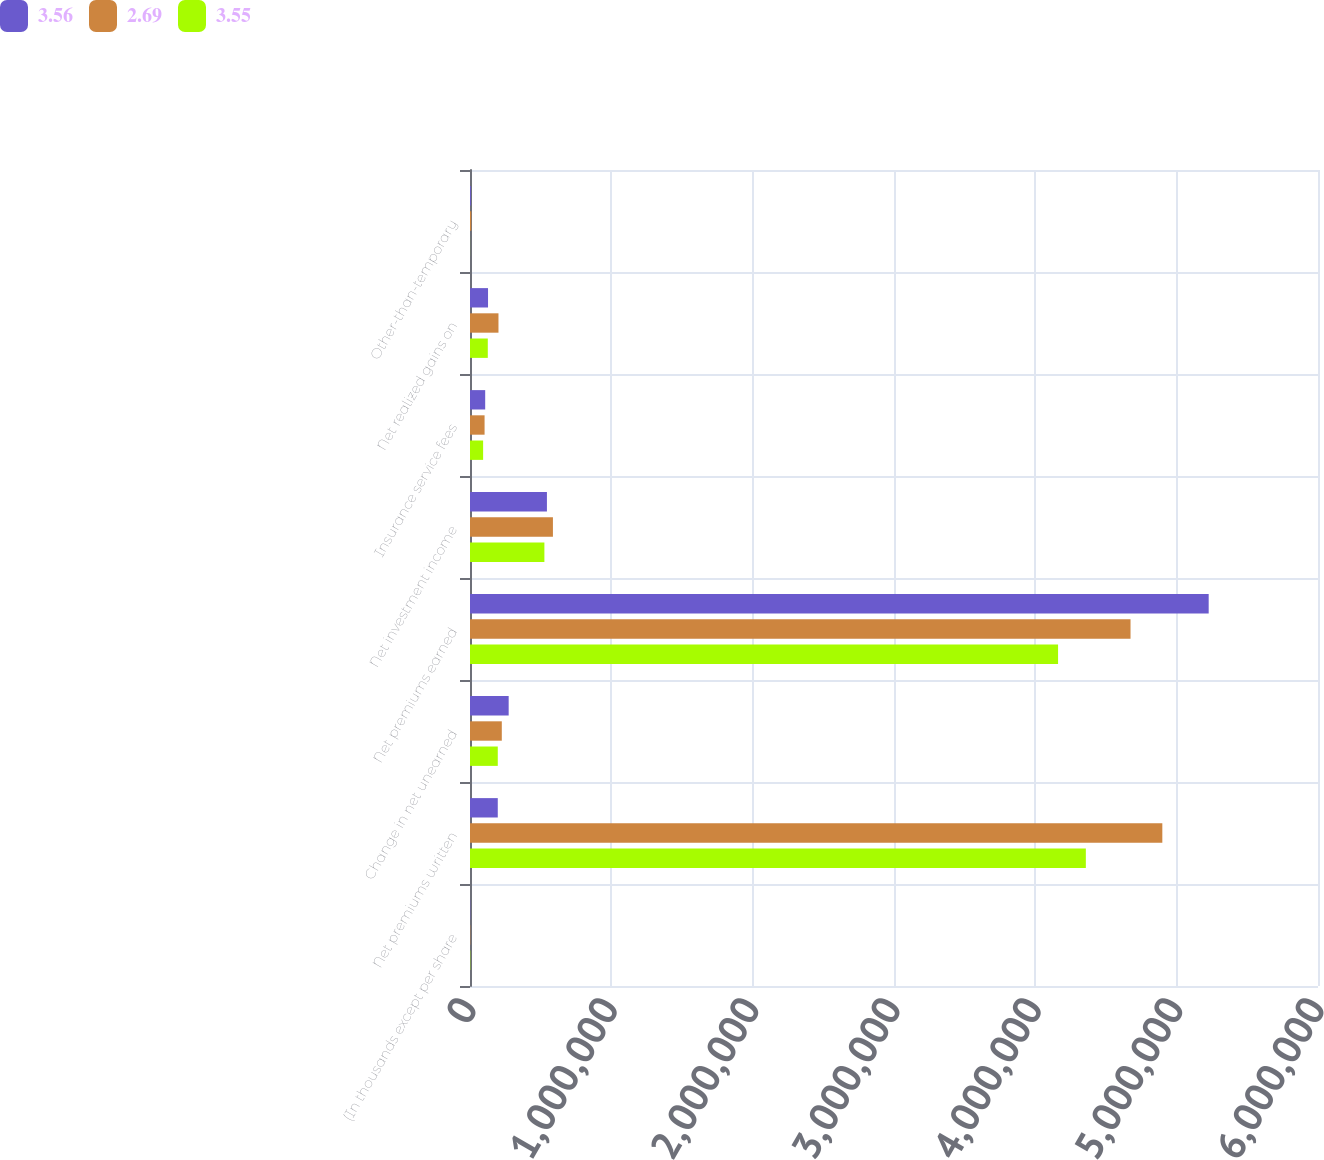<chart> <loc_0><loc_0><loc_500><loc_500><stacked_bar_chart><ecel><fcel>(In thousands except per share<fcel>Net premiums written<fcel>Change in net unearned<fcel>Net premiums earned<fcel>Net investment income<fcel>Insurance service fees<fcel>Net realized gains on<fcel>Other-than-temporary<nl><fcel>3.56<fcel>2013<fcel>196501<fcel>273636<fcel>5.22654e+06<fcel>544291<fcel>107513<fcel>127586<fcel>6042<nl><fcel>2.69<fcel>2012<fcel>4.89854e+06<fcel>225023<fcel>4.67352e+06<fcel>586763<fcel>103133<fcel>201451<fcel>9014<nl><fcel>3.55<fcel>2011<fcel>4.35737e+06<fcel>196501<fcel>4.16087e+06<fcel>526351<fcel>92843<fcel>125881<fcel>400<nl></chart> 